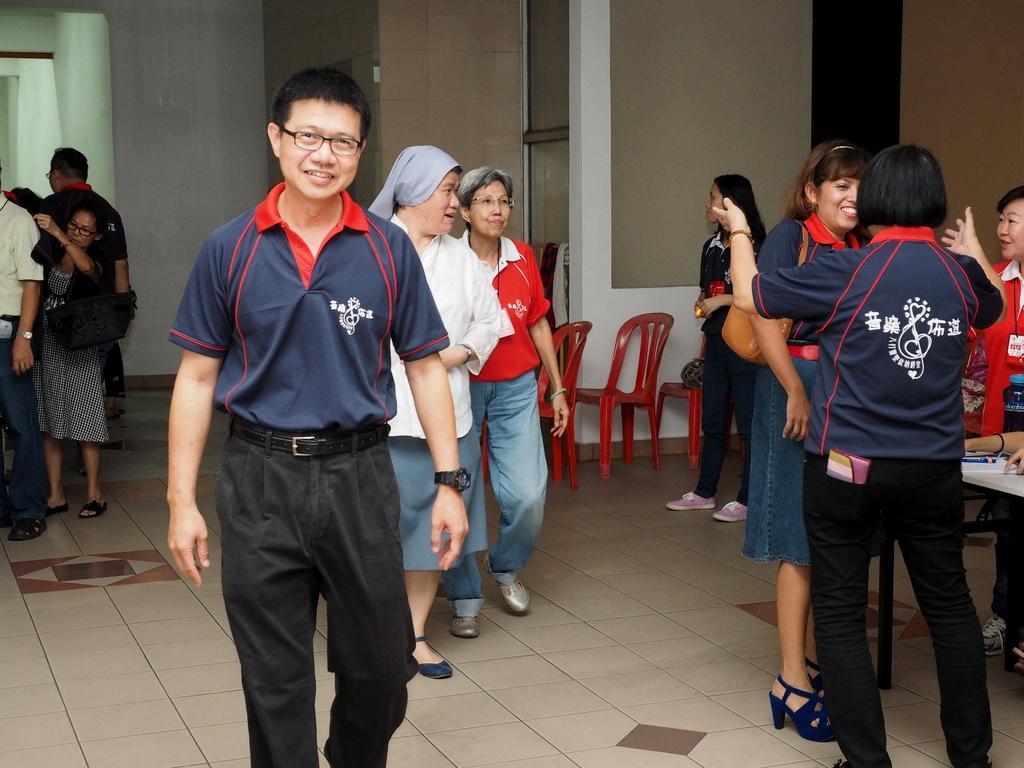Please provide a concise description of this image. In this image we can see these people are walking on the floor. In the background, we can see chairs, wall and glass windows. 